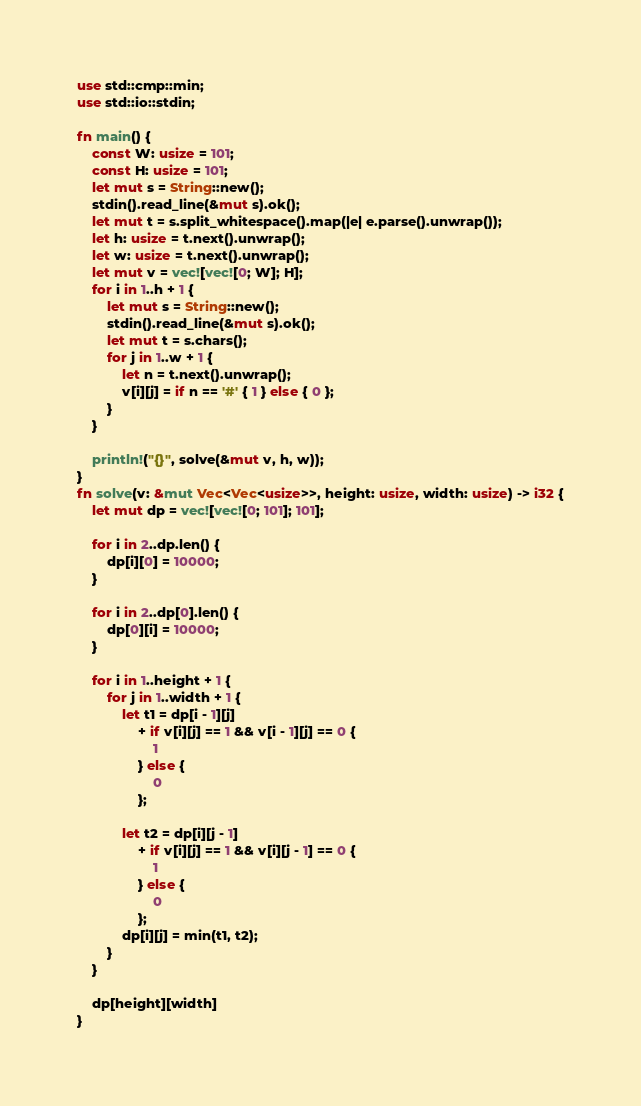<code> <loc_0><loc_0><loc_500><loc_500><_Rust_>use std::cmp::min;
use std::io::stdin;

fn main() {
    const W: usize = 101;
    const H: usize = 101;
    let mut s = String::new();
    stdin().read_line(&mut s).ok();
    let mut t = s.split_whitespace().map(|e| e.parse().unwrap());
    let h: usize = t.next().unwrap();
    let w: usize = t.next().unwrap();
    let mut v = vec![vec![0; W]; H];
    for i in 1..h + 1 {
        let mut s = String::new();
        stdin().read_line(&mut s).ok();
        let mut t = s.chars();
        for j in 1..w + 1 {
            let n = t.next().unwrap();
            v[i][j] = if n == '#' { 1 } else { 0 };
        }
    }

    println!("{}", solve(&mut v, h, w));
}
fn solve(v: &mut Vec<Vec<usize>>, height: usize, width: usize) -> i32 {
    let mut dp = vec![vec![0; 101]; 101];

    for i in 2..dp.len() {
        dp[i][0] = 10000;
    }

    for i in 2..dp[0].len() {
        dp[0][i] = 10000;
    }

    for i in 1..height + 1 {
        for j in 1..width + 1 {
            let t1 = dp[i - 1][j]
                + if v[i][j] == 1 && v[i - 1][j] == 0 {
                    1
                } else {
                    0
                };

            let t2 = dp[i][j - 1]
                + if v[i][j] == 1 && v[i][j - 1] == 0 {
                    1
                } else {
                    0
                };
            dp[i][j] = min(t1, t2);
        }
    }

    dp[height][width]
}
</code> 